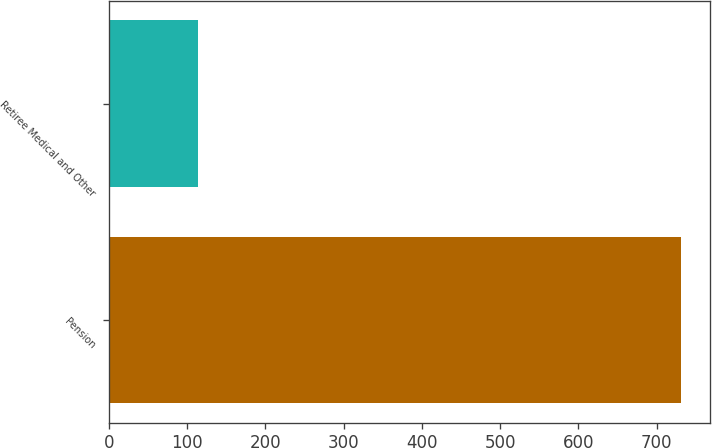<chart> <loc_0><loc_0><loc_500><loc_500><bar_chart><fcel>Pension<fcel>Retiree Medical and Other<nl><fcel>731<fcel>114<nl></chart> 